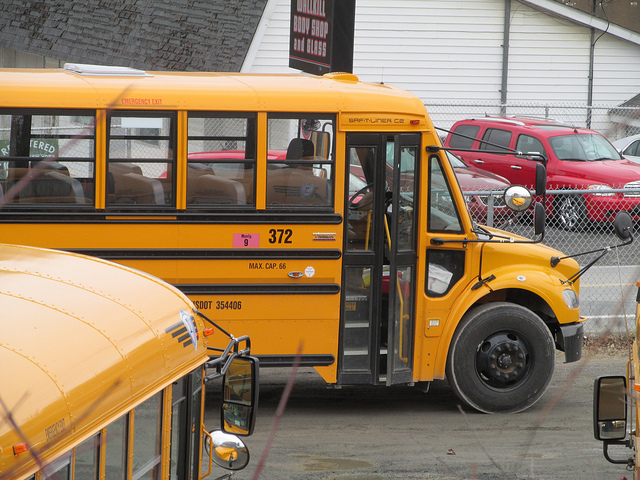Read and extract the text from this image. 372 CAP 354406 SOOT 9 